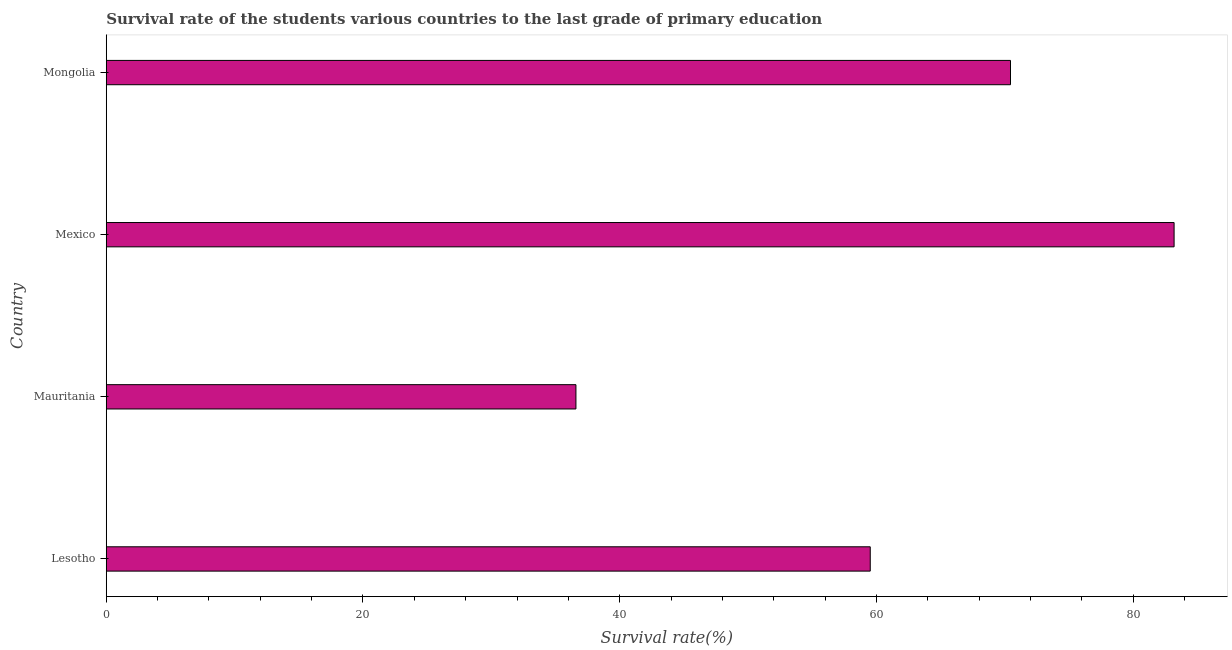Does the graph contain any zero values?
Offer a very short reply. No. Does the graph contain grids?
Ensure brevity in your answer.  No. What is the title of the graph?
Your answer should be compact. Survival rate of the students various countries to the last grade of primary education. What is the label or title of the X-axis?
Give a very brief answer. Survival rate(%). What is the survival rate in primary education in Mexico?
Your response must be concise. 83.19. Across all countries, what is the maximum survival rate in primary education?
Your response must be concise. 83.19. Across all countries, what is the minimum survival rate in primary education?
Ensure brevity in your answer.  36.59. In which country was the survival rate in primary education maximum?
Your answer should be compact. Mexico. In which country was the survival rate in primary education minimum?
Offer a terse response. Mauritania. What is the sum of the survival rate in primary education?
Give a very brief answer. 249.75. What is the difference between the survival rate in primary education in Lesotho and Mexico?
Make the answer very short. -23.67. What is the average survival rate in primary education per country?
Keep it short and to the point. 62.44. What is the median survival rate in primary education?
Your answer should be very brief. 64.98. What is the ratio of the survival rate in primary education in Lesotho to that in Mexico?
Your response must be concise. 0.71. Is the survival rate in primary education in Lesotho less than that in Mexico?
Provide a succinct answer. Yes. Is the difference between the survival rate in primary education in Mauritania and Mexico greater than the difference between any two countries?
Keep it short and to the point. Yes. What is the difference between the highest and the second highest survival rate in primary education?
Offer a very short reply. 12.74. What is the difference between the highest and the lowest survival rate in primary education?
Your answer should be compact. 46.6. Are all the bars in the graph horizontal?
Give a very brief answer. Yes. What is the Survival rate(%) of Lesotho?
Keep it short and to the point. 59.52. What is the Survival rate(%) of Mauritania?
Give a very brief answer. 36.59. What is the Survival rate(%) in Mexico?
Your answer should be very brief. 83.19. What is the Survival rate(%) of Mongolia?
Give a very brief answer. 70.45. What is the difference between the Survival rate(%) in Lesotho and Mauritania?
Ensure brevity in your answer.  22.93. What is the difference between the Survival rate(%) in Lesotho and Mexico?
Offer a terse response. -23.67. What is the difference between the Survival rate(%) in Lesotho and Mongolia?
Ensure brevity in your answer.  -10.93. What is the difference between the Survival rate(%) in Mauritania and Mexico?
Give a very brief answer. -46.6. What is the difference between the Survival rate(%) in Mauritania and Mongolia?
Give a very brief answer. -33.85. What is the difference between the Survival rate(%) in Mexico and Mongolia?
Your answer should be compact. 12.74. What is the ratio of the Survival rate(%) in Lesotho to that in Mauritania?
Make the answer very short. 1.63. What is the ratio of the Survival rate(%) in Lesotho to that in Mexico?
Your answer should be very brief. 0.71. What is the ratio of the Survival rate(%) in Lesotho to that in Mongolia?
Your answer should be very brief. 0.84. What is the ratio of the Survival rate(%) in Mauritania to that in Mexico?
Offer a terse response. 0.44. What is the ratio of the Survival rate(%) in Mauritania to that in Mongolia?
Make the answer very short. 0.52. What is the ratio of the Survival rate(%) in Mexico to that in Mongolia?
Your answer should be compact. 1.18. 